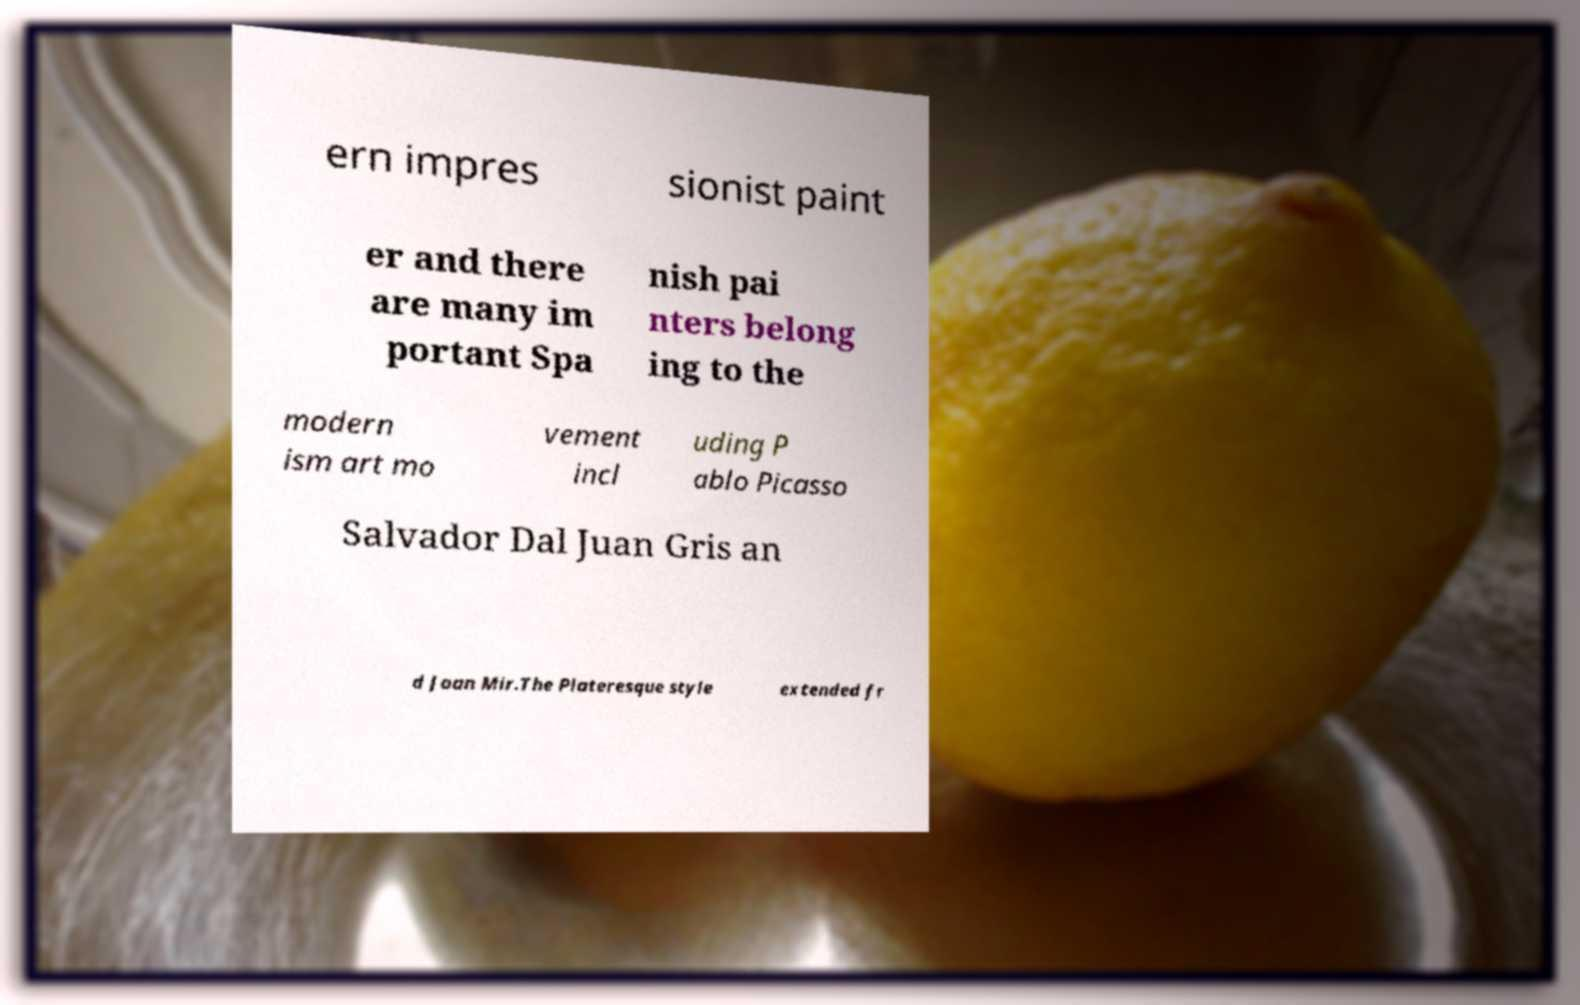Could you assist in decoding the text presented in this image and type it out clearly? ern impres sionist paint er and there are many im portant Spa nish pai nters belong ing to the modern ism art mo vement incl uding P ablo Picasso Salvador Dal Juan Gris an d Joan Mir.The Plateresque style extended fr 